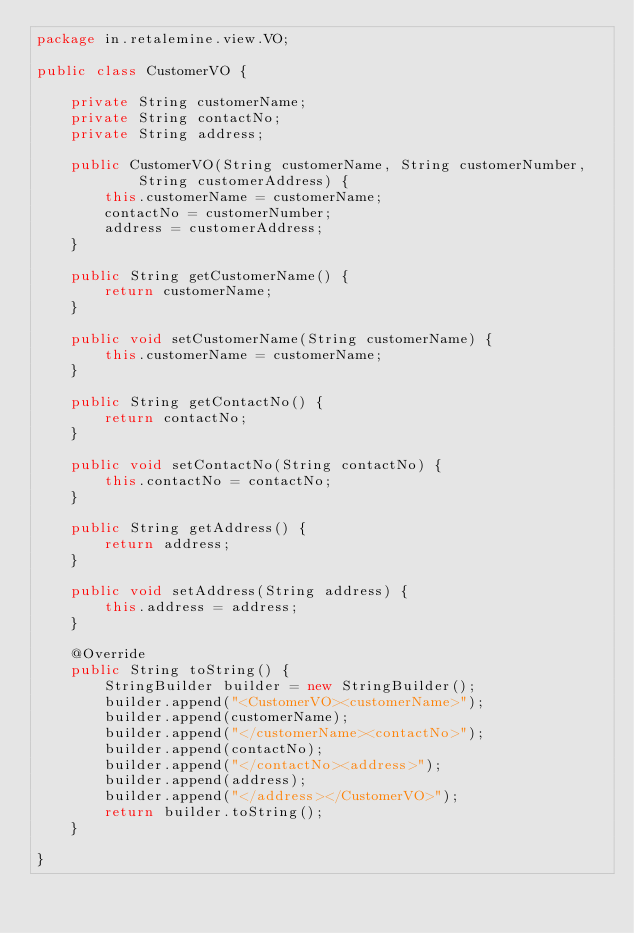Convert code to text. <code><loc_0><loc_0><loc_500><loc_500><_Java_>package in.retalemine.view.VO;

public class CustomerVO {

	private String customerName;
	private String contactNo;
	private String address;

	public CustomerVO(String customerName, String customerNumber,
			String customerAddress) {
		this.customerName = customerName;
		contactNo = customerNumber;
		address = customerAddress;
	}

	public String getCustomerName() {
		return customerName;
	}

	public void setCustomerName(String customerName) {
		this.customerName = customerName;
	}

	public String getContactNo() {
		return contactNo;
	}

	public void setContactNo(String contactNo) {
		this.contactNo = contactNo;
	}

	public String getAddress() {
		return address;
	}

	public void setAddress(String address) {
		this.address = address;
	}

	@Override
	public String toString() {
		StringBuilder builder = new StringBuilder();
		builder.append("<CustomerVO><customerName>");
		builder.append(customerName);
		builder.append("</customerName><contactNo>");
		builder.append(contactNo);
		builder.append("</contactNo><address>");
		builder.append(address);
		builder.append("</address></CustomerVO>");
		return builder.toString();
	}

}
</code> 